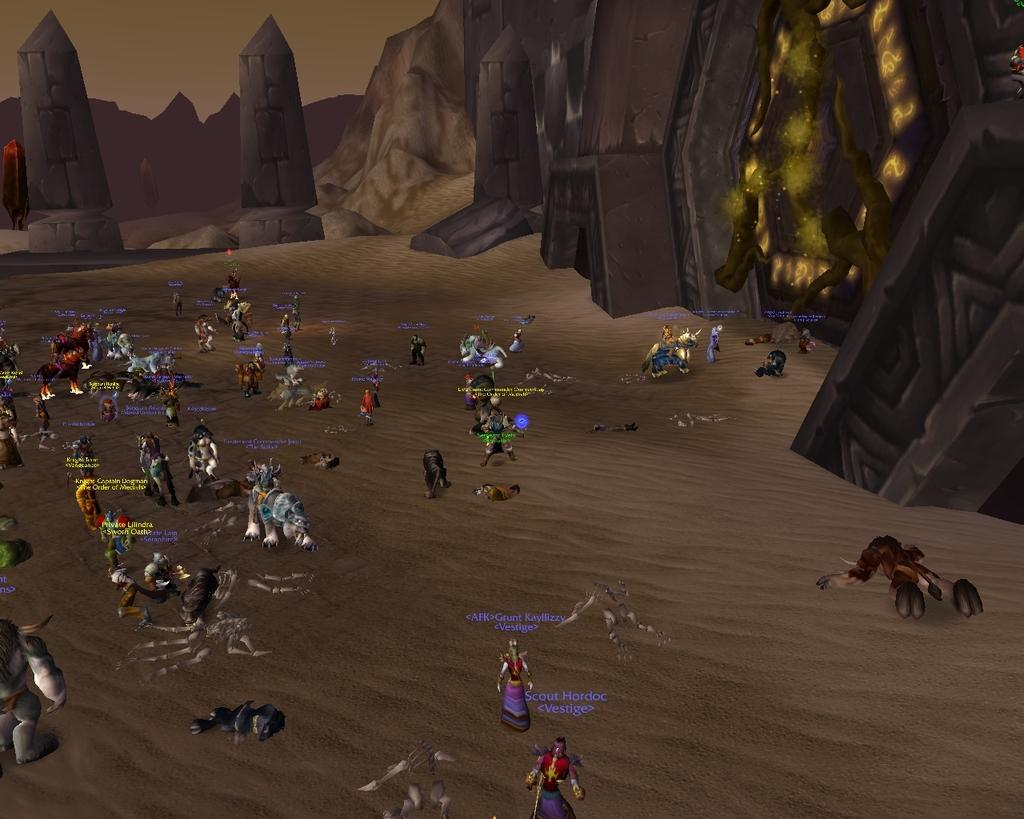What is the primary setting of the image? The primary setting of the image is on the sand. What can be seen on the sand in the image? There are persons on the sand in the image. What else is present in the image besides the persons on the sand? There are texts and objects in the image. What can be seen in the background of the image? In the background of the image, there are mountains, towers, a wall, and sky visible. Are there any objects in the background of the image? Yes, there are objects in the background of the image. How does the destruction of the wall affect the persons on the sand in the image? There is no destruction of the wall present in the image, so it cannot be determined how it would affect the persons on the sand. 